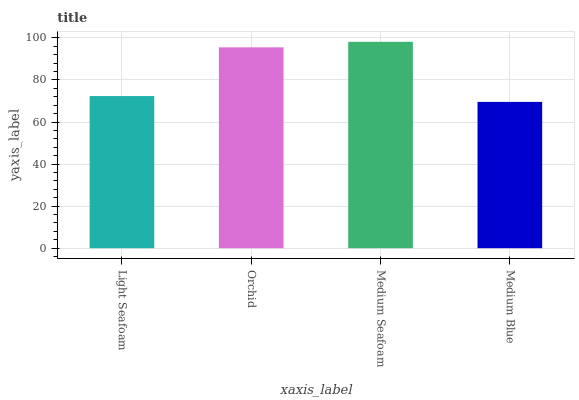Is Medium Blue the minimum?
Answer yes or no. Yes. Is Medium Seafoam the maximum?
Answer yes or no. Yes. Is Orchid the minimum?
Answer yes or no. No. Is Orchid the maximum?
Answer yes or no. No. Is Orchid greater than Light Seafoam?
Answer yes or no. Yes. Is Light Seafoam less than Orchid?
Answer yes or no. Yes. Is Light Seafoam greater than Orchid?
Answer yes or no. No. Is Orchid less than Light Seafoam?
Answer yes or no. No. Is Orchid the high median?
Answer yes or no. Yes. Is Light Seafoam the low median?
Answer yes or no. Yes. Is Light Seafoam the high median?
Answer yes or no. No. Is Medium Seafoam the low median?
Answer yes or no. No. 